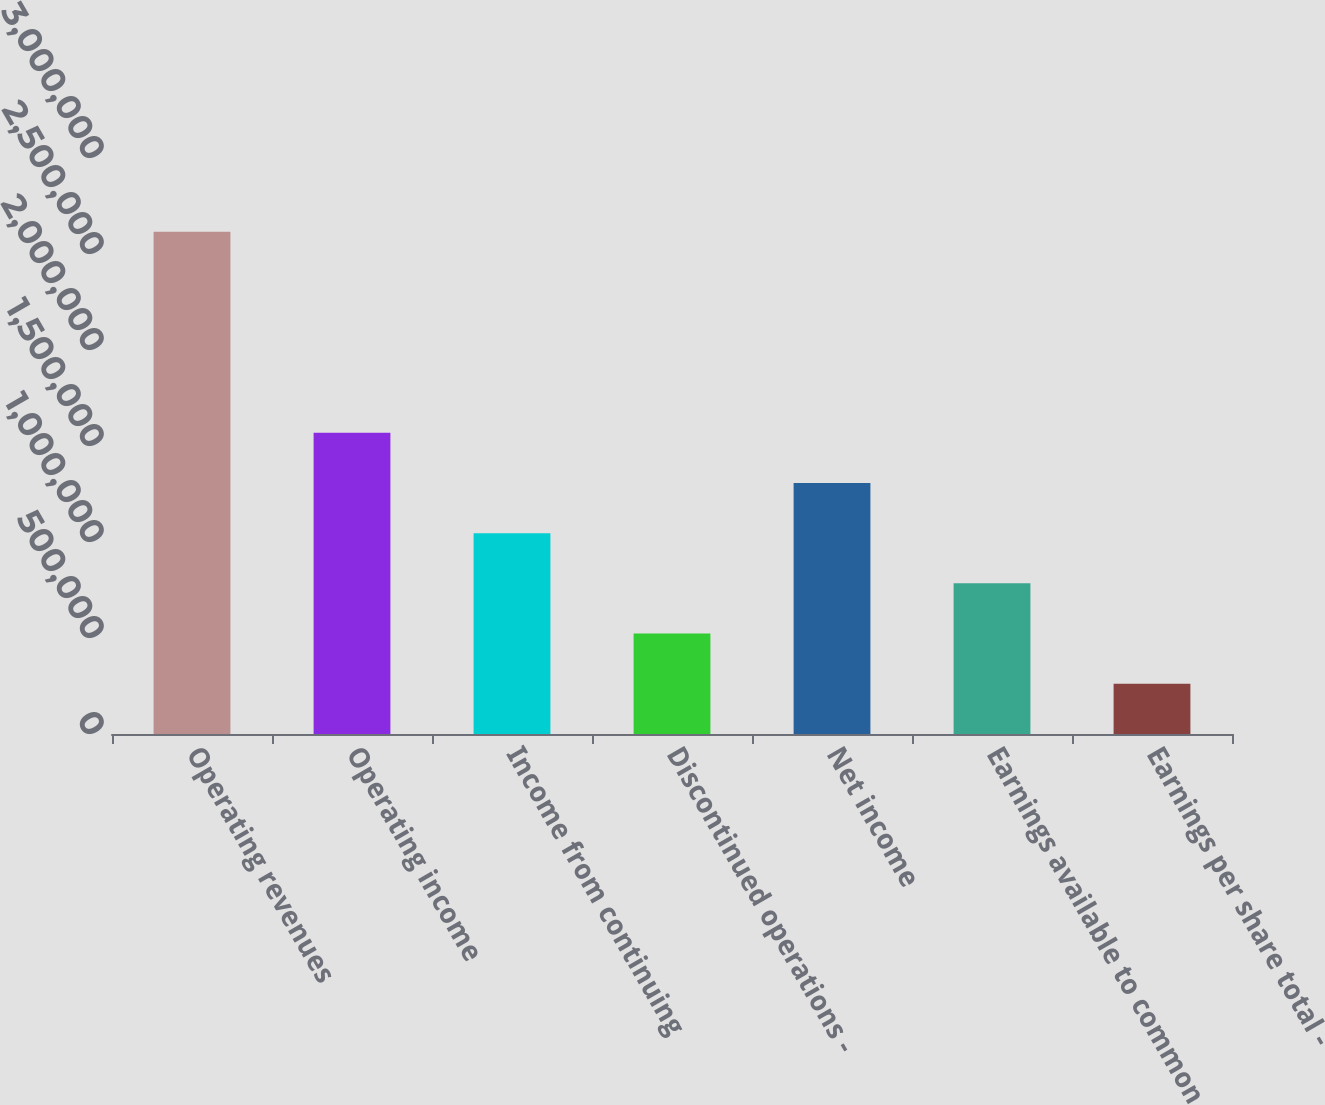Convert chart. <chart><loc_0><loc_0><loc_500><loc_500><bar_chart><fcel>Operating revenues<fcel>Operating income<fcel>Income from continuing<fcel>Discontinued operations -<fcel>Net income<fcel>Earnings available to common<fcel>Earnings per share total -<nl><fcel>2.61552e+06<fcel>1.56931e+06<fcel>1.04621e+06<fcel>523103<fcel>1.30776e+06<fcel>784655<fcel>261552<nl></chart> 